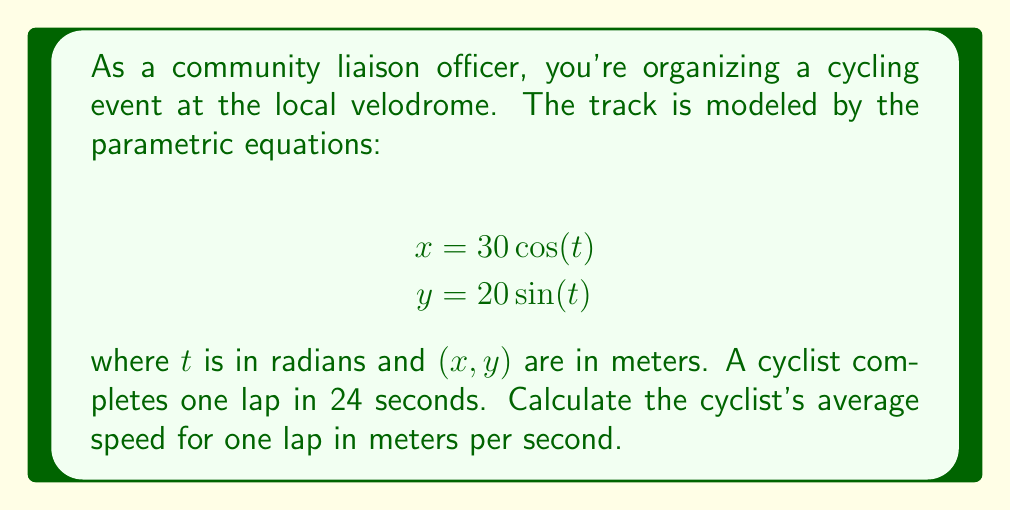Give your solution to this math problem. To solve this problem, we'll follow these steps:

1) First, we need to find the length of the velodrome track. The track forms an ellipse, and we can calculate its perimeter using the approximate formula:

   $$P \approx 2\pi\sqrt{\frac{a^2 + b^2}{2}}$$

   where $a$ and $b$ are the semi-major and semi-minor axes of the ellipse.

2) From the parametric equations, we can see that $a = 30$ and $b = 20$.

3) Plugging these values into the formula:

   $$P \approx 2\pi\sqrt{\frac{30^2 + 20^2}{2}}$$
   $$P \approx 2\pi\sqrt{\frac{1300}{2}}$$
   $$P \approx 2\pi\sqrt{650}$$
   $$P \approx 159.77 \text{ meters}$$

4) Now that we have the distance (159.77 meters) and the time (24 seconds), we can calculate the average speed using the formula:

   $$\text{Average Speed} = \frac{\text{Distance}}{\text{Time}}$$

5) Plugging in our values:

   $$\text{Average Speed} = \frac{159.77 \text{ meters}}{24 \text{ seconds}}$$
   $$\text{Average Speed} \approx 6.66 \text{ meters/second}$$

Therefore, the cyclist's average speed is approximately 6.66 meters per second.
Answer: 6.66 meters/second 